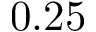Convert formula to latex. <formula><loc_0><loc_0><loc_500><loc_500>0 . 2 5</formula> 